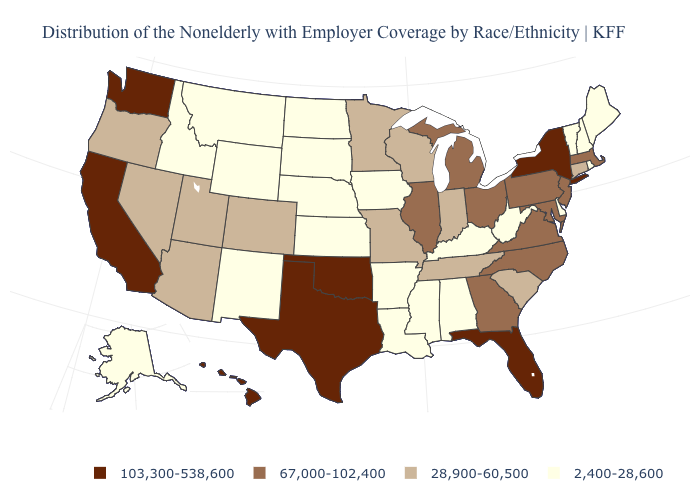Does New York have a higher value than Alabama?
Keep it brief. Yes. What is the value of Georgia?
Be succinct. 67,000-102,400. Among the states that border Connecticut , does New York have the lowest value?
Quick response, please. No. Does Kansas have a higher value than Maine?
Give a very brief answer. No. Among the states that border Kansas , which have the lowest value?
Short answer required. Nebraska. Name the states that have a value in the range 2,400-28,600?
Write a very short answer. Alabama, Alaska, Arkansas, Delaware, Idaho, Iowa, Kansas, Kentucky, Louisiana, Maine, Mississippi, Montana, Nebraska, New Hampshire, New Mexico, North Dakota, Rhode Island, South Dakota, Vermont, West Virginia, Wyoming. What is the value of Mississippi?
Be succinct. 2,400-28,600. Does Nebraska have the highest value in the USA?
Quick response, please. No. Name the states that have a value in the range 103,300-538,600?
Be succinct. California, Florida, Hawaii, New York, Oklahoma, Texas, Washington. Does New York have the highest value in the USA?
Answer briefly. Yes. Among the states that border Michigan , does Indiana have the lowest value?
Short answer required. Yes. Name the states that have a value in the range 67,000-102,400?
Concise answer only. Georgia, Illinois, Maryland, Massachusetts, Michigan, New Jersey, North Carolina, Ohio, Pennsylvania, Virginia. Name the states that have a value in the range 2,400-28,600?
Quick response, please. Alabama, Alaska, Arkansas, Delaware, Idaho, Iowa, Kansas, Kentucky, Louisiana, Maine, Mississippi, Montana, Nebraska, New Hampshire, New Mexico, North Dakota, Rhode Island, South Dakota, Vermont, West Virginia, Wyoming. Name the states that have a value in the range 28,900-60,500?
Quick response, please. Arizona, Colorado, Connecticut, Indiana, Minnesota, Missouri, Nevada, Oregon, South Carolina, Tennessee, Utah, Wisconsin. How many symbols are there in the legend?
Quick response, please. 4. 